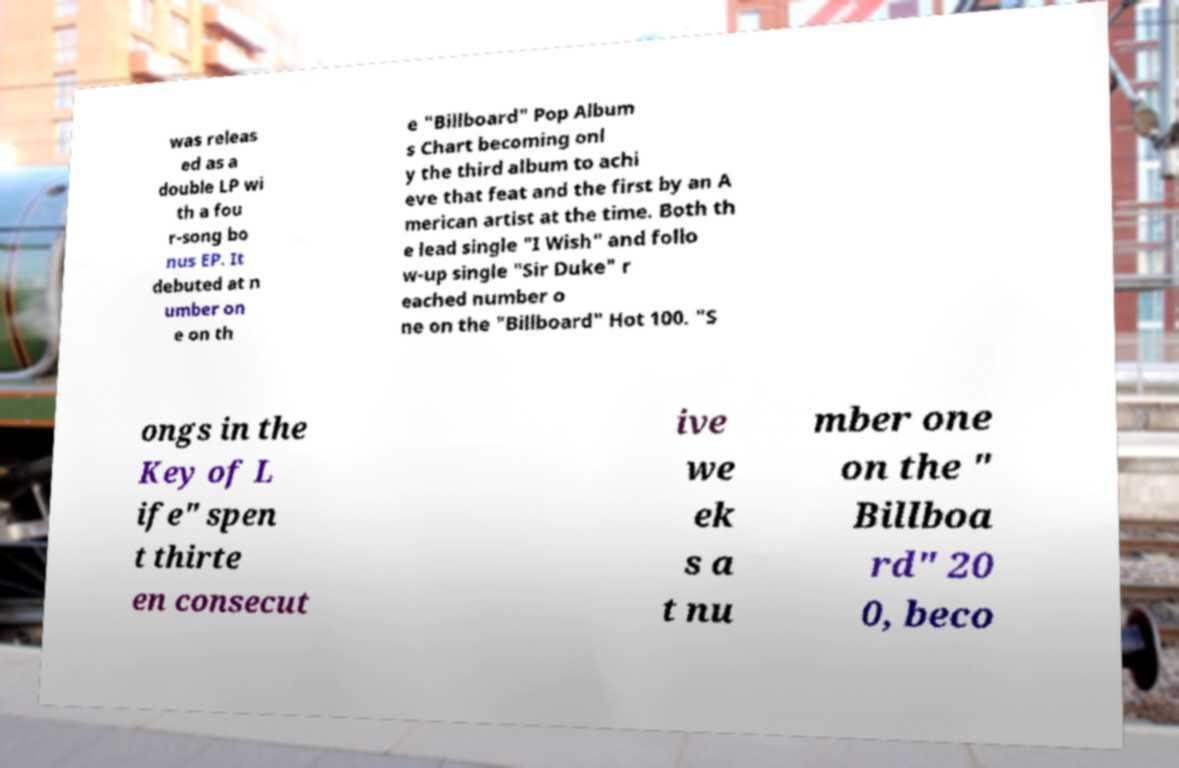Can you read and provide the text displayed in the image?This photo seems to have some interesting text. Can you extract and type it out for me? was releas ed as a double LP wi th a fou r-song bo nus EP. It debuted at n umber on e on th e "Billboard" Pop Album s Chart becoming onl y the third album to achi eve that feat and the first by an A merican artist at the time. Both th e lead single "I Wish" and follo w-up single "Sir Duke" r eached number o ne on the "Billboard" Hot 100. "S ongs in the Key of L ife" spen t thirte en consecut ive we ek s a t nu mber one on the " Billboa rd" 20 0, beco 